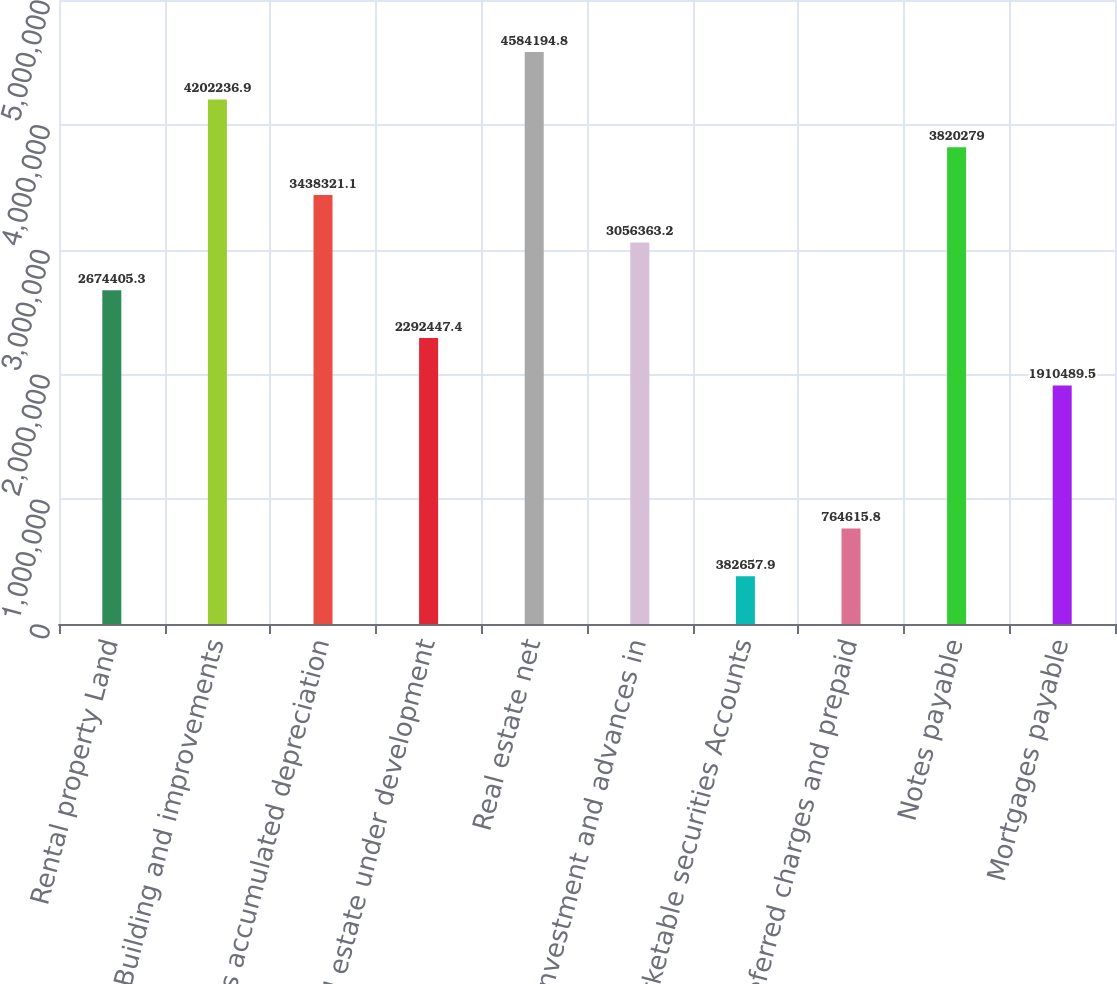Convert chart. <chart><loc_0><loc_0><loc_500><loc_500><bar_chart><fcel>Rental property Land<fcel>Building and improvements<fcel>Less accumulated depreciation<fcel>Real estate under development<fcel>Real estate net<fcel>Investment and advances in<fcel>Marketable securities Accounts<fcel>Deferred charges and prepaid<fcel>Notes payable<fcel>Mortgages payable<nl><fcel>2.67441e+06<fcel>4.20224e+06<fcel>3.43832e+06<fcel>2.29245e+06<fcel>4.58419e+06<fcel>3.05636e+06<fcel>382658<fcel>764616<fcel>3.82028e+06<fcel>1.91049e+06<nl></chart> 